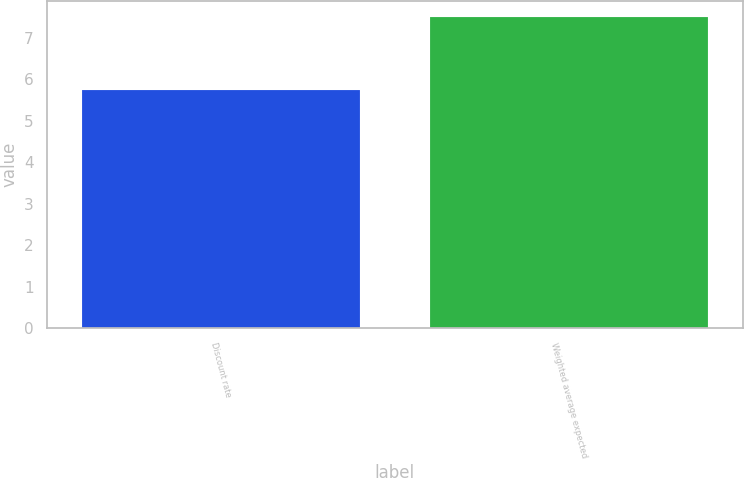Convert chart to OTSL. <chart><loc_0><loc_0><loc_500><loc_500><bar_chart><fcel>Discount rate<fcel>Weighted average expected<nl><fcel>5.75<fcel>7.5<nl></chart> 